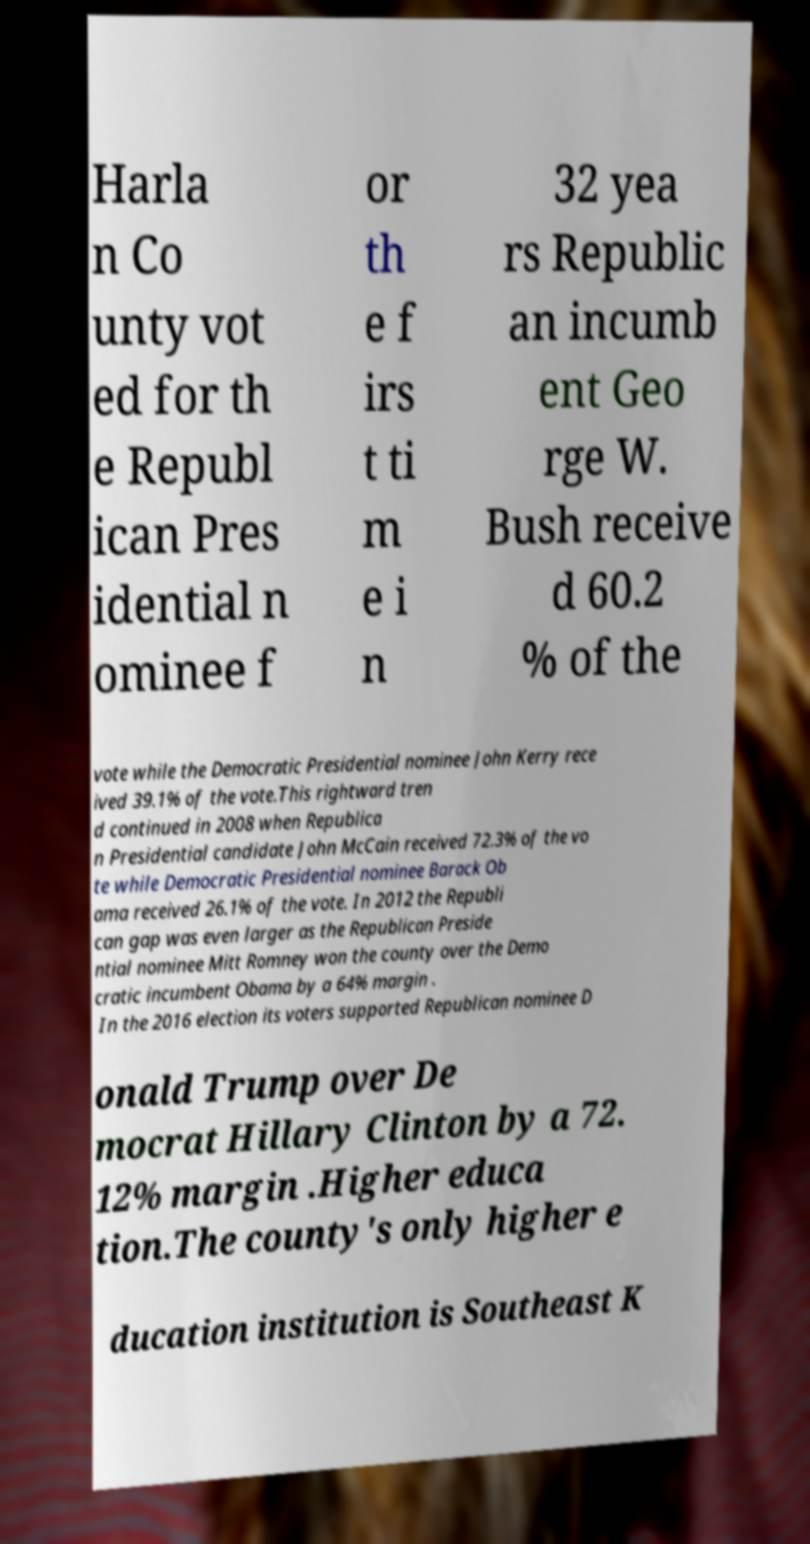What messages or text are displayed in this image? I need them in a readable, typed format. Harla n Co unty vot ed for th e Republ ican Pres idential n ominee f or th e f irs t ti m e i n 32 yea rs Republic an incumb ent Geo rge W. Bush receive d 60.2 % of the vote while the Democratic Presidential nominee John Kerry rece ived 39.1% of the vote.This rightward tren d continued in 2008 when Republica n Presidential candidate John McCain received 72.3% of the vo te while Democratic Presidential nominee Barack Ob ama received 26.1% of the vote. In 2012 the Republi can gap was even larger as the Republican Preside ntial nominee Mitt Romney won the county over the Demo cratic incumbent Obama by a 64% margin . In the 2016 election its voters supported Republican nominee D onald Trump over De mocrat Hillary Clinton by a 72. 12% margin .Higher educa tion.The county's only higher e ducation institution is Southeast K 